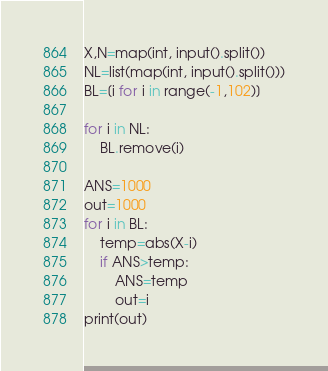Convert code to text. <code><loc_0><loc_0><loc_500><loc_500><_Python_>X,N=map(int, input().split())
NL=list(map(int, input().split()))
BL=[i for i in range(-1,102)]

for i in NL:
    BL.remove(i)

ANS=1000
out=1000
for i in BL:
    temp=abs(X-i)
    if ANS>temp:
        ANS=temp
        out=i
print(out)</code> 